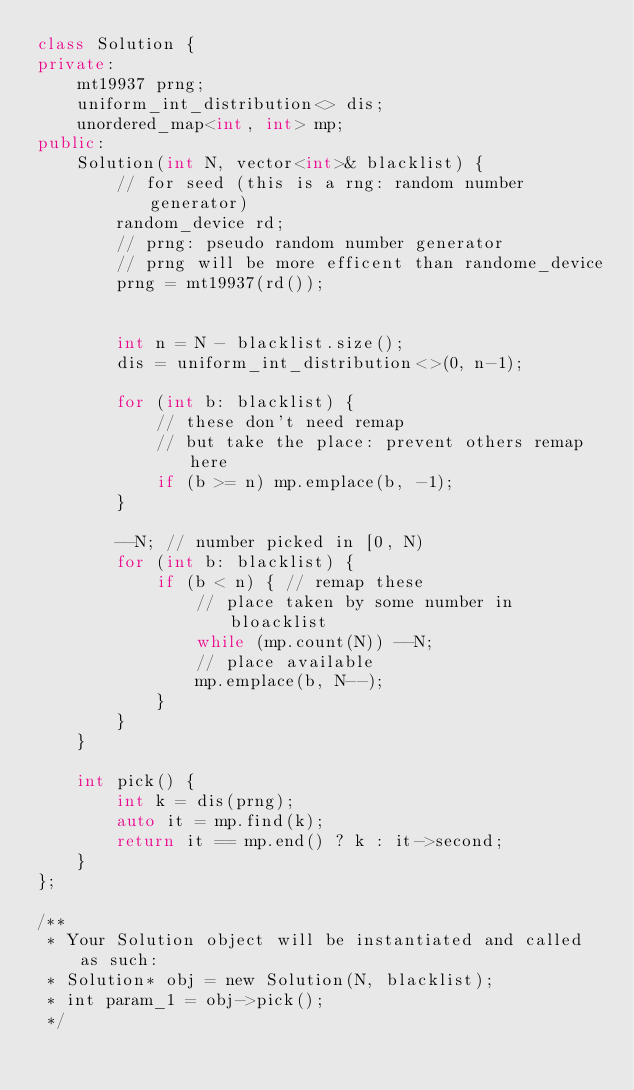<code> <loc_0><loc_0><loc_500><loc_500><_C++_>class Solution {
private:
    mt19937 prng;
    uniform_int_distribution<> dis;
    unordered_map<int, int> mp;
public:
    Solution(int N, vector<int>& blacklist) {
        // for seed (this is a rng: random number generator)
        random_device rd;
        // prng: pseudo random number generator
        // prng will be more efficent than randome_device
        prng = mt19937(rd());
        

        int n = N - blacklist.size();
        dis = uniform_int_distribution<>(0, n-1);

        for (int b: blacklist) {
            // these don't need remap
            // but take the place: prevent others remap here
            if (b >= n) mp.emplace(b, -1);
        }

        --N; // number picked in [0, N)
        for (int b: blacklist) {
            if (b < n) { // remap these
                // place taken by some number in bloacklist
                while (mp.count(N)) --N; 
                // place available
                mp.emplace(b, N--);
            }
        }
    }
    
    int pick() {
        int k = dis(prng);
        auto it = mp.find(k);
        return it == mp.end() ? k : it->second;
    }
};

/**
 * Your Solution object will be instantiated and called as such:
 * Solution* obj = new Solution(N, blacklist);
 * int param_1 = obj->pick();
 */
</code> 